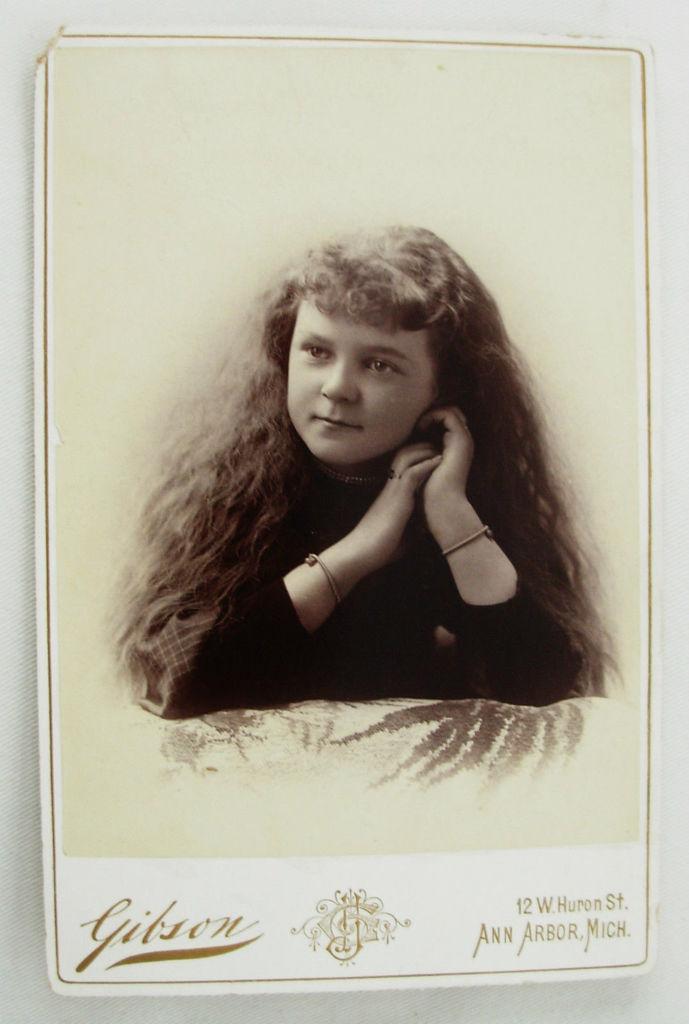Can you describe this image briefly? In this picture we can see a photograph of the small girl in the front and giving a pose to the camera. On the front bottom side we can see "Gibson" is written. 